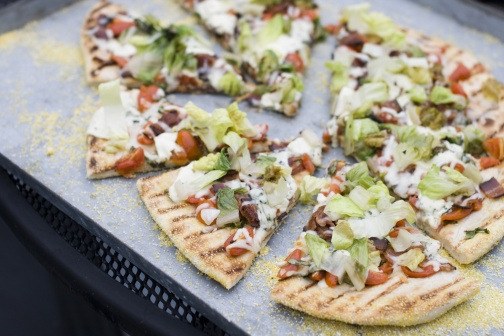Describe the textures you can see in the image. The image's textures are varied and distinct. The pizza crust looks crispy with a golden-brown hue, bearing light grill marks that hint at a slightly charred and crunchy texture. The melted cheese appears smooth and creamy, seamlessly blending with the toppings. The fresh lettuce leaves are crisp and ruffled, adding a contrasting crunch. The tomatoes provide a juicy, moist component. The tray beneath is utilitarian with a textured surface, possibly hinting at its heat-resistant quality, ensuring that the pizza stays warm. Overall, the interplay of textures enhances the visual and likely tactile appeal of the dish. If this pizza were a part of a story, what would its backstory be? In a quaint little town, nestled between rolling hills and crystal clear rivers, lies a rustic pizzeria known as 'The Artisan’s Oven.' The legendary pizza depicted here is their specialty – ‘The Harvest Delight.’ Every morning, the head chef, Isabella, picks fresh vegetables from her organic garden. The lettuce is handpicked for its crispness, and the tomatoes for their sweetness and juiciness. The dough is prepared from a secret family recipe passed down for generations, and it is baked in a wood-fired oven, giving it the unique texture and flavor. This particular pizza, crafted with love and precision, became the town’s symbol of culinary excellence and brought together the community every weekend to celebrate good food and good company. Could you imagine this pizza being served at an interstellar space gathering? Imagine a grand galactic event, where beings from different corners of the universe gather to share their cultures. The centerpiece of the culinary showcase is this Earth-made pizza, 'The Galactic Harmony Pie.' Created to symbolize unity and diversity, the toppings represent various elements from Earth - the greens symbolize the planet's lush flora, while the reds represent the resilience and warmth of humanity. The cheese, a universal delight, represents the bonds that hold civilizations together. As the pizza is served, its aroma fills the cosmic hall, mesmerizing beings with its completely Earthly essence. It becomes a shared experience, transcending languages and species, epitomizing the universal love for good food and bringing together different worlds in harmony. 